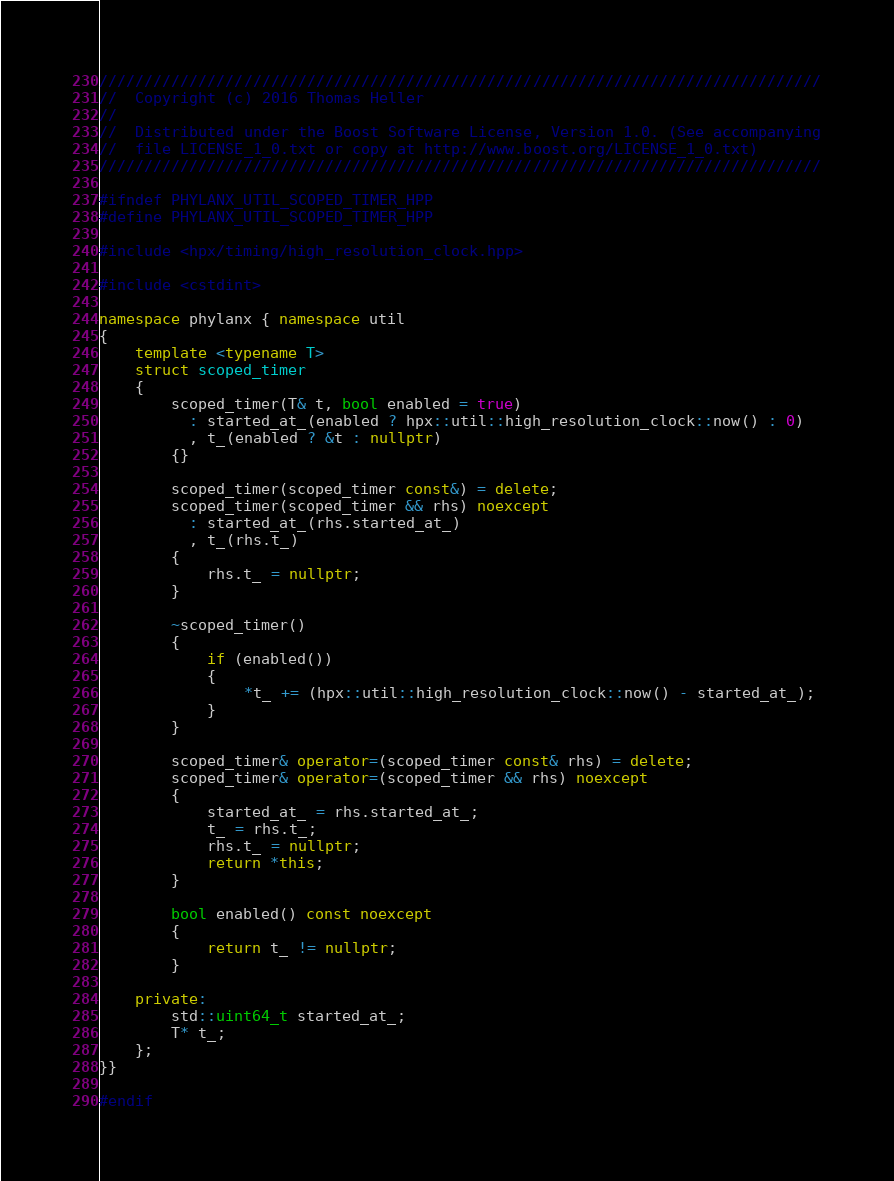<code> <loc_0><loc_0><loc_500><loc_500><_C++_>////////////////////////////////////////////////////////////////////////////////
//  Copyright (c) 2016 Thomas Heller
//
//  Distributed under the Boost Software License, Version 1.0. (See accompanying
//  file LICENSE_1_0.txt or copy at http://www.boost.org/LICENSE_1_0.txt)
////////////////////////////////////////////////////////////////////////////////

#ifndef PHYLANX_UTIL_SCOPED_TIMER_HPP
#define PHYLANX_UTIL_SCOPED_TIMER_HPP

#include <hpx/timing/high_resolution_clock.hpp>

#include <cstdint>

namespace phylanx { namespace util
{
    template <typename T>
    struct scoped_timer
    {
        scoped_timer(T& t, bool enabled = true)
          : started_at_(enabled ? hpx::util::high_resolution_clock::now() : 0)
          , t_(enabled ? &t : nullptr)
        {}

        scoped_timer(scoped_timer const&) = delete;
        scoped_timer(scoped_timer && rhs) noexcept
          : started_at_(rhs.started_at_)
          , t_(rhs.t_)
        {
            rhs.t_ = nullptr;
        }

        ~scoped_timer()
        {
            if (enabled())
            {
                *t_ += (hpx::util::high_resolution_clock::now() - started_at_);
            }
        }

        scoped_timer& operator=(scoped_timer const& rhs) = delete;
        scoped_timer& operator=(scoped_timer && rhs) noexcept
        {
            started_at_ = rhs.started_at_;
            t_ = rhs.t_;
            rhs.t_ = nullptr;
            return *this;
        }

        bool enabled() const noexcept
        {
            return t_ != nullptr;
        }

    private:
        std::uint64_t started_at_;
        T* t_;
    };
}}

#endif
</code> 